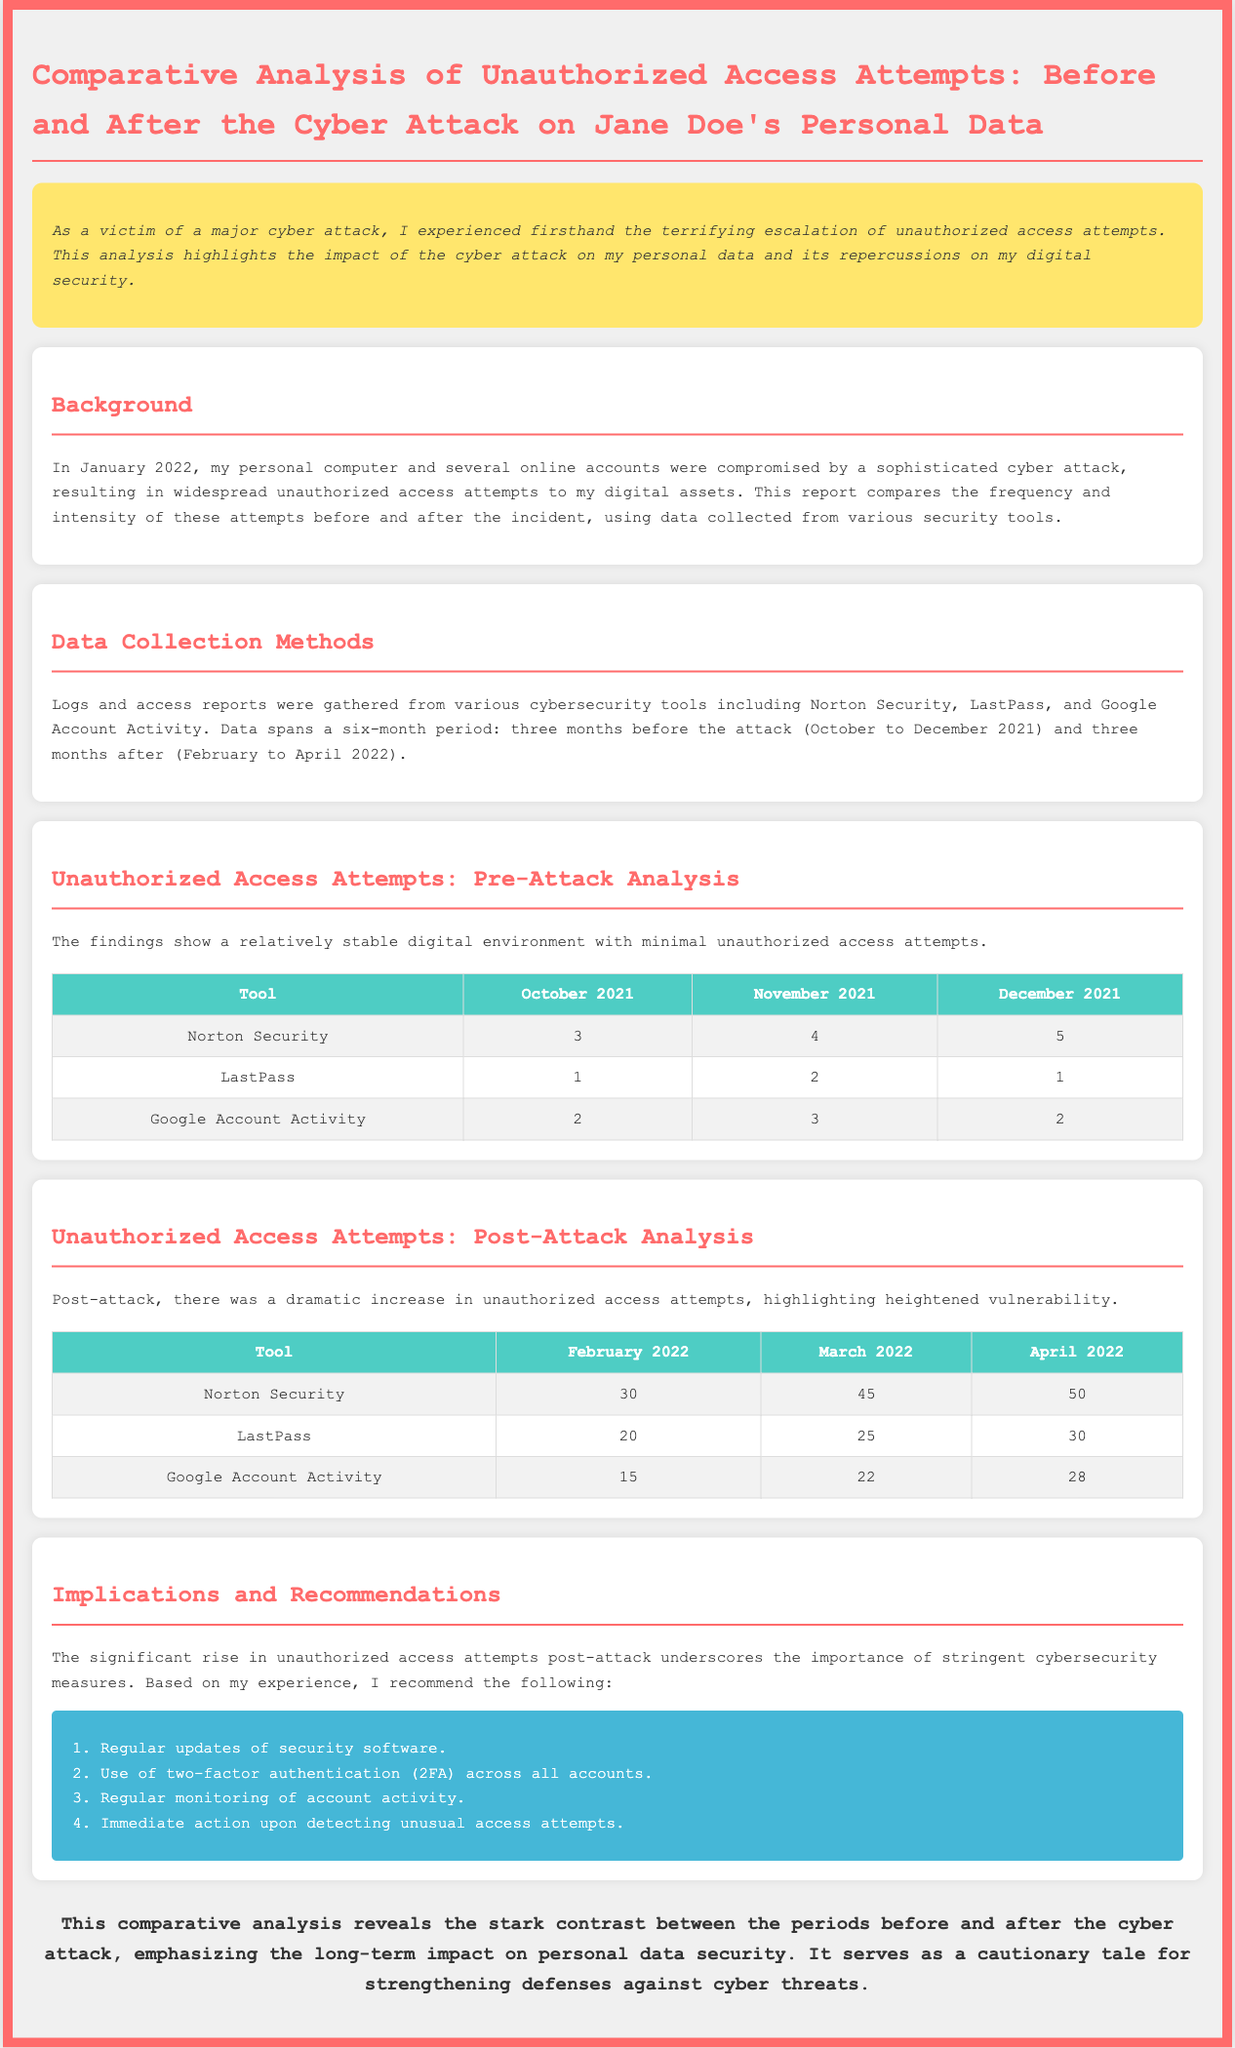what month did the cyber attack occur? The cyber attack occurred in January 2022, as stated in the document.
Answer: January 2022 how many unauthorized access attempts were reported by Norton Security in December 2021? The document states that 5 unauthorized access attempts were reported by Norton Security in December 2021.
Answer: 5 what was the number of unauthorized access attempts in March 2022 for LastPass? The document indicates that there were 25 unauthorized access attempts for LastPass in March 2022.
Answer: 25 what is one recommendation mentioned after the analysis? The document lists several recommendations, one being to use two-factor authentication (2FA) across all accounts.
Answer: Use of two-factor authentication (2FA) how many total months are analyzed in the report? The report analyzes a total of six months, three months before and three months after the cyber attack.
Answer: Six months what was the highest number of unauthorized access attempts recorded in April 2022? According to the document, the highest recorded number of unauthorized access attempts in April 2022 was 50, as reported by Norton Security.
Answer: 50 what was the purpose of the report? The document highlights the impact of a cyber attack on personal data security and emphasizes the need for strengthened defenses.
Answer: Impact of a cyber attack on personal data security what cybersecurity tools were used to collect data? The document mentions Norton Security, LastPass, and Google Account Activity as tools used for data collection.
Answer: Norton Security, LastPass, Google Account Activity how many unauthorized access attempts did Google Account Activity record in February 2022? The document shows that Google Account Activity recorded 15 unauthorized access attempts in February 2022.
Answer: 15 